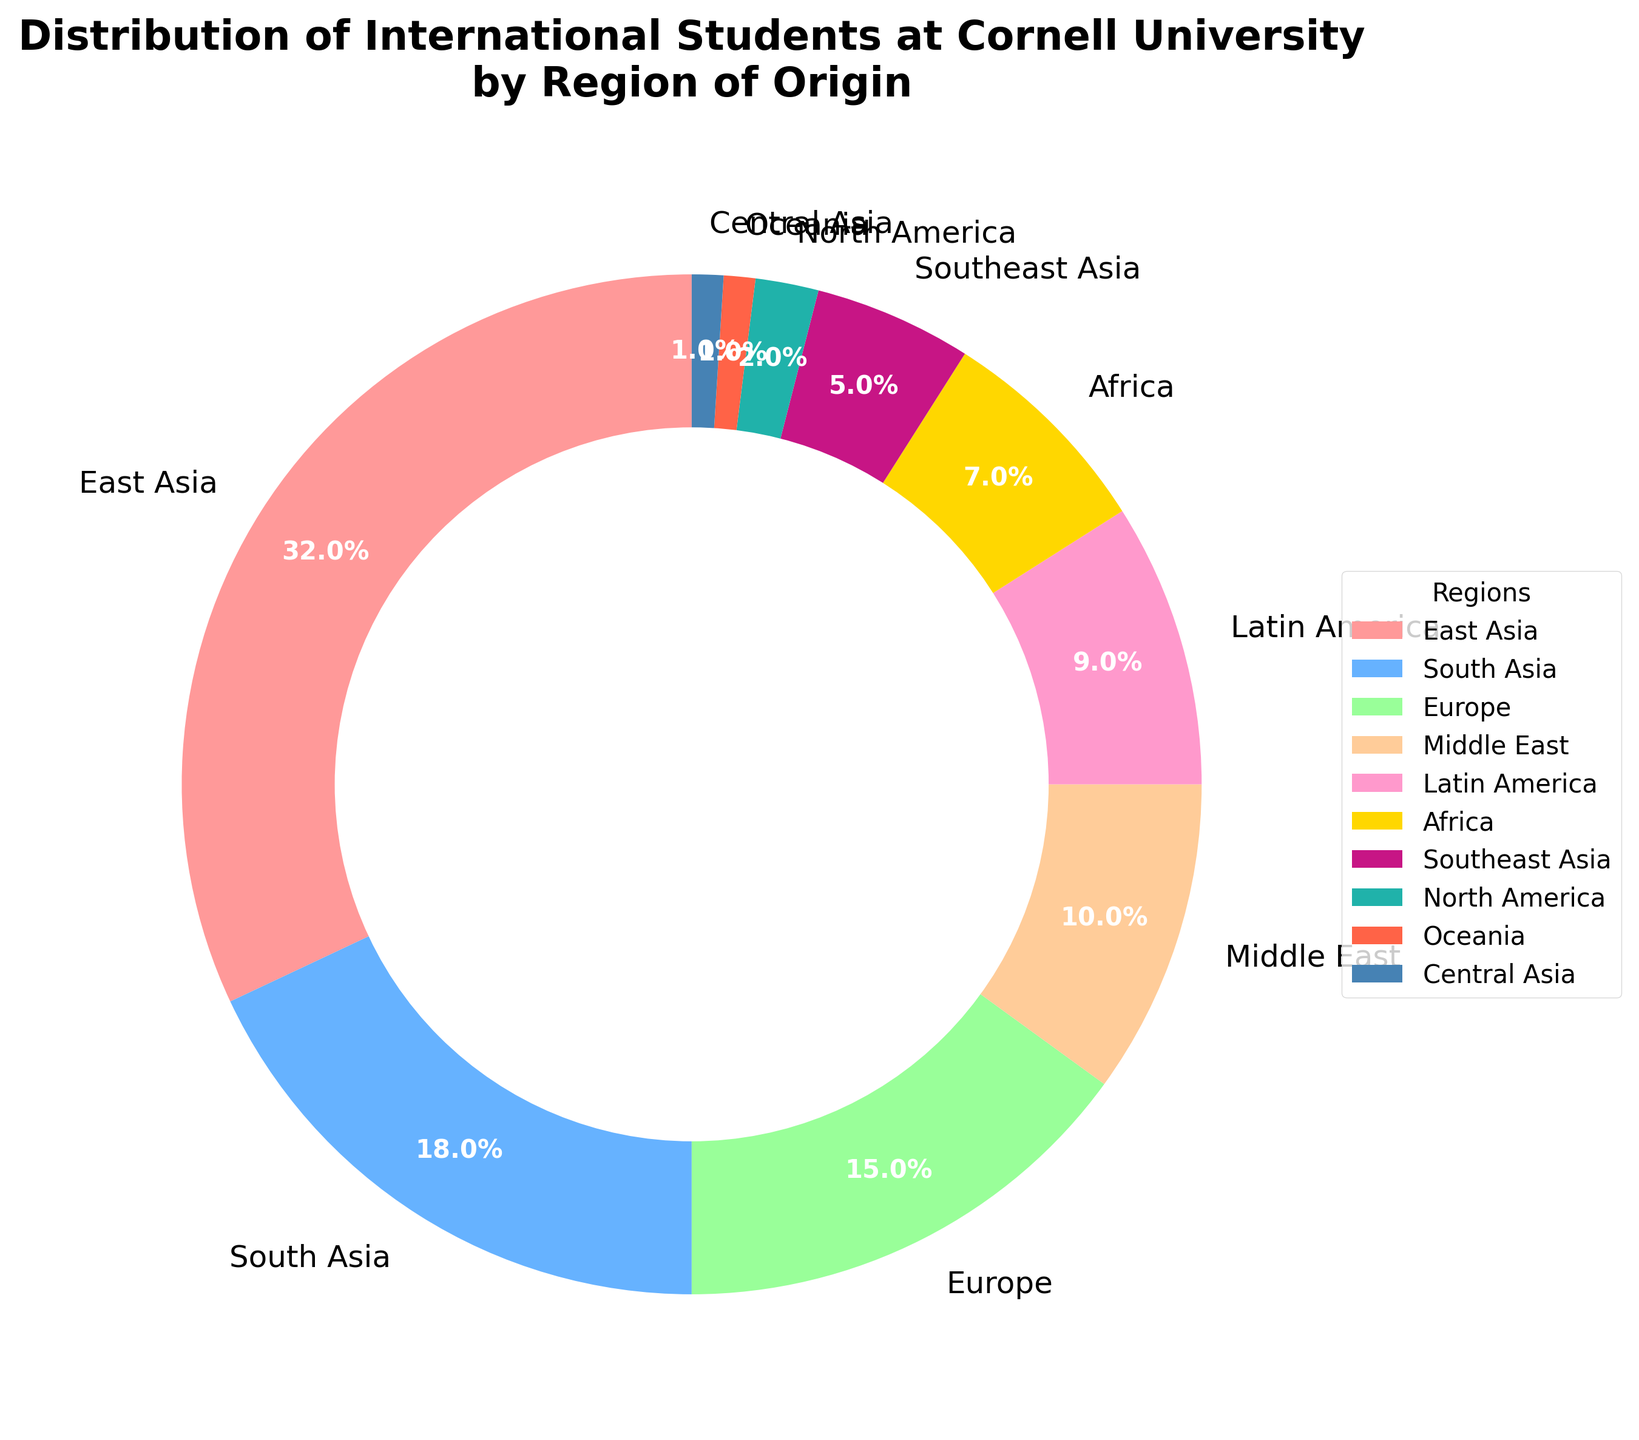What's the region with the highest percentage of international students? The figure shows the distribution of international students by region. The region with the highest percentage is represented by the largest slice of the pie chart, which is labeled "East Asia" and shows 32%.
Answer: East Asia Which region has the second-highest percentage of international students? After East Asia, the next largest slice of the pie chart represents South Asia, showing 18%. This indicates that South Asia has the second-highest percentage of international students.
Answer: South Asia What is the combined percentage of international students from Europe and the Middle East? To find this, add the percentages for Europe and the Middle East from the chart. Europe has 15% and the Middle East has 10%, so 15% + 10% = 25%.
Answer: 25% How much larger is the percentage of students from East Asia compared to Africa? The percentage for East Asia is 32%, and for Africa, it's 7%. The difference is 32% - 7% = 25%.
Answer: 25% Which regions have the smallest representation among international students at Cornell University? The smallest slices on the pie chart represent the least percentage values. Both Oceania and Central Asia have the smallest slices, each representing 1%.
Answer: Oceania and Central Asia What is the percentage of international students from North America, Latin America, and Africa combined? To find this, add the percentages for North America (2%), Latin America (9%), and Africa (7%). So, 2% + 9% + 7% = 18%.
Answer: 18% Is the percentage of students from Southeast Asia greater than that from North America? If so, by how much? The percentage for Southeast Asia is 5%, while North America has 2%. The difference is 5% - 2% = 3%. Since 5% is greater than 2%, Southeast Asia has 3% more students than North America.
Answer: Yes, by 3% Which colors represent the regions with the highest and lowest percentages of students? The color associated with East Asia (the highest percentage at 32%) is the first color in the sequence, which is a shade of red. The colors for Oceania and Central Asia (the lowest percentages at 1% each) are at the end of the sequence, being a darker blue and light blue, respectively.
Answer: Red for East Asia, blue shades for Oceania and Central Asia What is the difference between the total percentages of students from South Asia and Southeast Asia? The percentage for South Asia is 18%, and for Southeast Asia, it is 5%. The difference is 18% - 5% = 13%.
Answer: 13% Among the top three regions with the highest percentages, what is the average percentage of international students? The top three regions are East Asia (32%), South Asia (18%), and Europe (15%). Average percentage = (32% + 18% + 15%) / 3 = 65% / 3 ≈ 21.67%.
Answer: 21.67% 